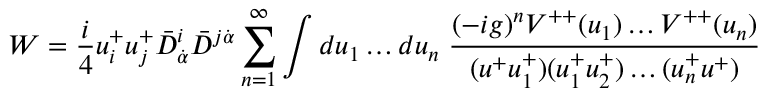Convert formula to latex. <formula><loc_0><loc_0><loc_500><loc_500>W = { \frac { i } { 4 } } u _ { i } ^ { + } u _ { j } ^ { + } \bar { D } _ { \dot { \alpha } } ^ { i } \bar { D } ^ { j \dot { \alpha } } \sum _ { n = 1 } ^ { \infty } \int d u _ { 1 } \dots d u _ { n } \, { \frac { ( - i g ) ^ { n } V ^ { + + } ( u _ { 1 } ) \dots V ^ { + + } ( u _ { n } ) } { ( u ^ { + } u _ { 1 } ^ { + } ) ( u _ { 1 } ^ { + } u _ { 2 } ^ { + } ) \dots ( u _ { n } ^ { + } u ^ { + } ) } }</formula> 